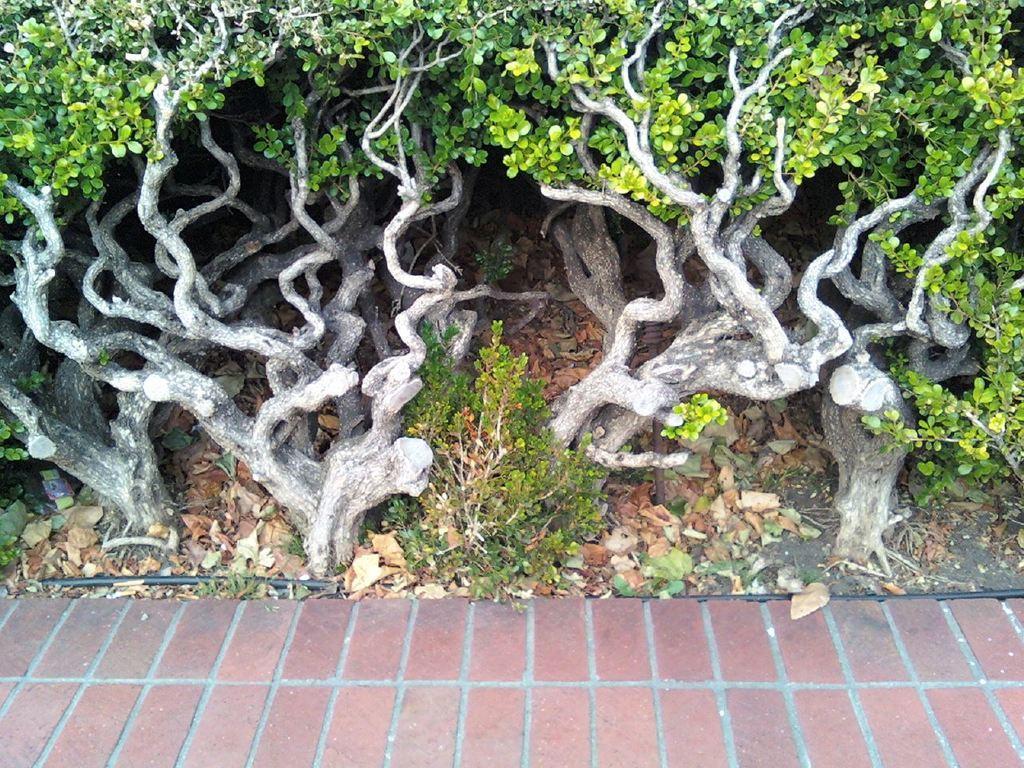Could you give a brief overview of what you see in this image? In the foreground of the picture there is pavement. The picture consists of dry leaves, plants and cable. In the picture we can see roots of the tree. 